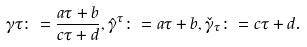Convert formula to latex. <formula><loc_0><loc_0><loc_500><loc_500>\gamma \tau \colon = \frac { a \tau + b } { c \tau + d } , \hat { \gamma } ^ { \tau } \colon = a \tau + b , \check { \gamma } _ { \tau } \colon = c \tau + d .</formula> 